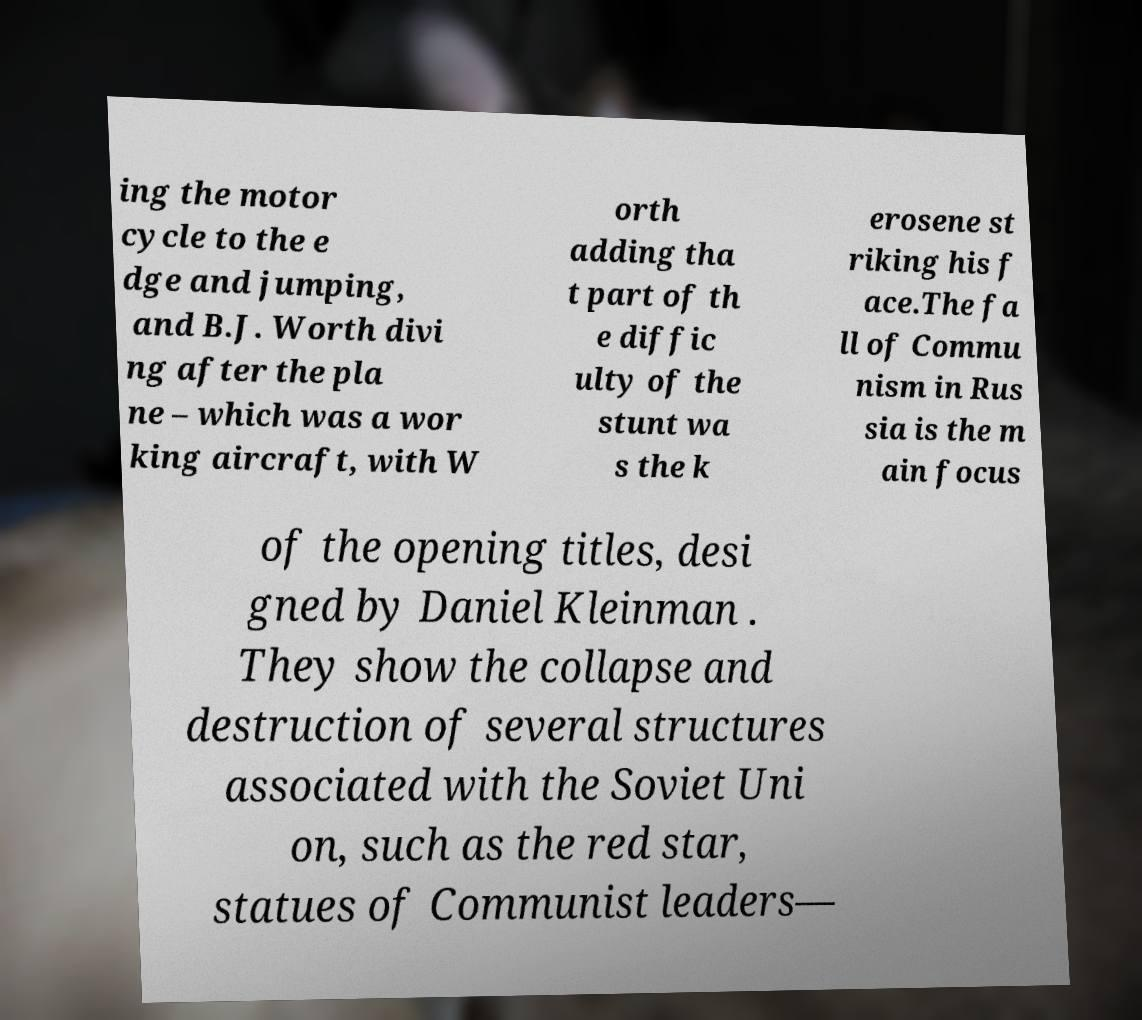I need the written content from this picture converted into text. Can you do that? ing the motor cycle to the e dge and jumping, and B.J. Worth divi ng after the pla ne – which was a wor king aircraft, with W orth adding tha t part of th e diffic ulty of the stunt wa s the k erosene st riking his f ace.The fa ll of Commu nism in Rus sia is the m ain focus of the opening titles, desi gned by Daniel Kleinman . They show the collapse and destruction of several structures associated with the Soviet Uni on, such as the red star, statues of Communist leaders— 